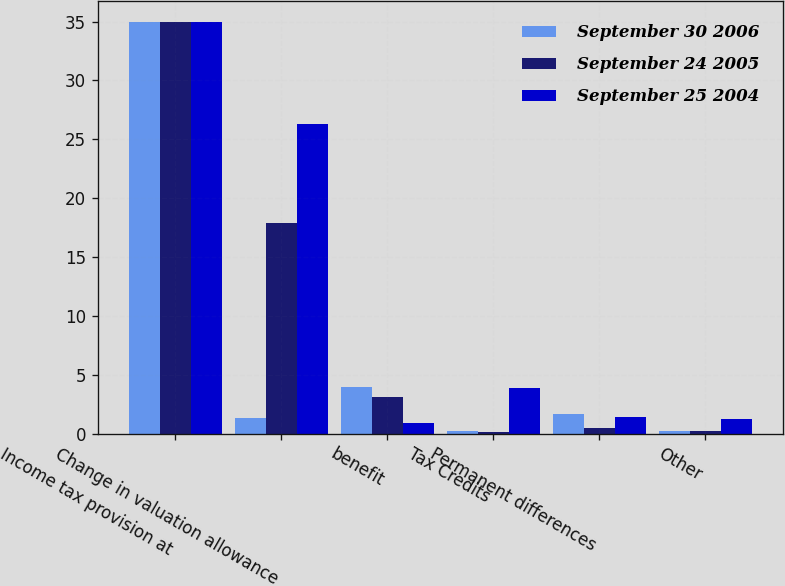<chart> <loc_0><loc_0><loc_500><loc_500><stacked_bar_chart><ecel><fcel>Income tax provision at<fcel>Change in valuation allowance<fcel>benefit<fcel>Tax Credits<fcel>Permanent differences<fcel>Other<nl><fcel>September 30 2006<fcel>35<fcel>1.3<fcel>4<fcel>0.2<fcel>1.7<fcel>0.2<nl><fcel>September 24 2005<fcel>35<fcel>17.9<fcel>3.1<fcel>0.1<fcel>0.5<fcel>0.2<nl><fcel>September 25 2004<fcel>35<fcel>26.3<fcel>0.9<fcel>3.9<fcel>1.4<fcel>1.2<nl></chart> 